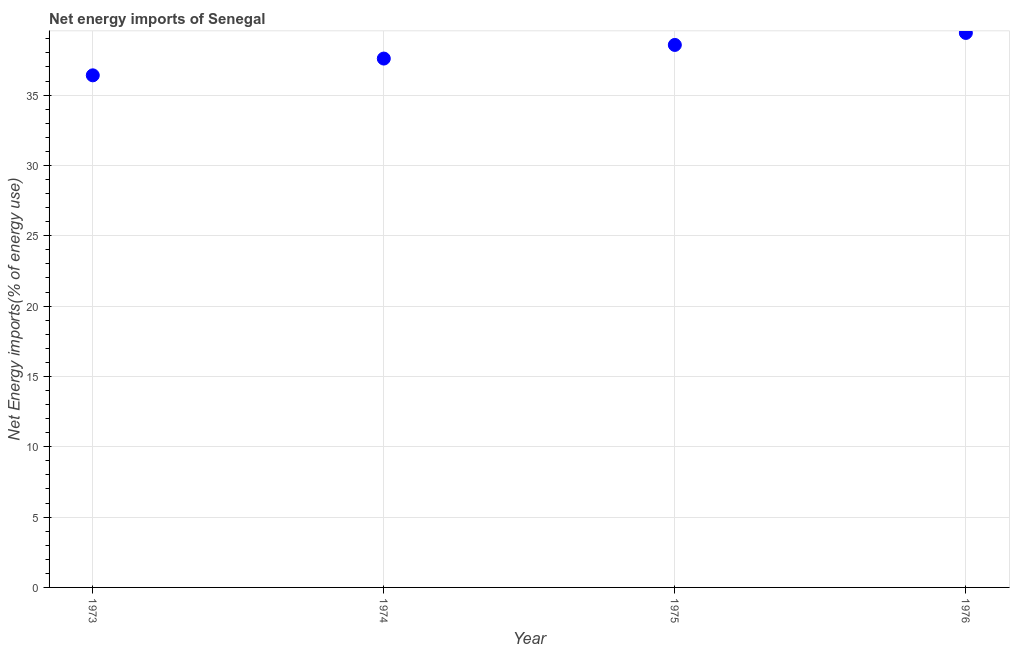What is the energy imports in 1976?
Provide a succinct answer. 39.42. Across all years, what is the maximum energy imports?
Provide a succinct answer. 39.42. Across all years, what is the minimum energy imports?
Keep it short and to the point. 36.4. In which year was the energy imports maximum?
Keep it short and to the point. 1976. In which year was the energy imports minimum?
Give a very brief answer. 1973. What is the sum of the energy imports?
Ensure brevity in your answer.  151.98. What is the difference between the energy imports in 1975 and 1976?
Make the answer very short. -0.85. What is the average energy imports per year?
Offer a terse response. 38. What is the median energy imports?
Your response must be concise. 38.08. What is the ratio of the energy imports in 1973 to that in 1975?
Give a very brief answer. 0.94. Is the difference between the energy imports in 1973 and 1974 greater than the difference between any two years?
Give a very brief answer. No. What is the difference between the highest and the second highest energy imports?
Make the answer very short. 0.85. What is the difference between the highest and the lowest energy imports?
Keep it short and to the point. 3.01. In how many years, is the energy imports greater than the average energy imports taken over all years?
Offer a very short reply. 2. How many years are there in the graph?
Offer a terse response. 4. Are the values on the major ticks of Y-axis written in scientific E-notation?
Your response must be concise. No. Does the graph contain any zero values?
Keep it short and to the point. No. Does the graph contain grids?
Your answer should be compact. Yes. What is the title of the graph?
Ensure brevity in your answer.  Net energy imports of Senegal. What is the label or title of the Y-axis?
Offer a terse response. Net Energy imports(% of energy use). What is the Net Energy imports(% of energy use) in 1973?
Ensure brevity in your answer.  36.4. What is the Net Energy imports(% of energy use) in 1974?
Offer a terse response. 37.6. What is the Net Energy imports(% of energy use) in 1975?
Ensure brevity in your answer.  38.57. What is the Net Energy imports(% of energy use) in 1976?
Provide a succinct answer. 39.42. What is the difference between the Net Energy imports(% of energy use) in 1973 and 1974?
Keep it short and to the point. -1.19. What is the difference between the Net Energy imports(% of energy use) in 1973 and 1975?
Provide a succinct answer. -2.16. What is the difference between the Net Energy imports(% of energy use) in 1973 and 1976?
Your answer should be very brief. -3.01. What is the difference between the Net Energy imports(% of energy use) in 1974 and 1975?
Your response must be concise. -0.97. What is the difference between the Net Energy imports(% of energy use) in 1974 and 1976?
Offer a very short reply. -1.82. What is the difference between the Net Energy imports(% of energy use) in 1975 and 1976?
Your response must be concise. -0.85. What is the ratio of the Net Energy imports(% of energy use) in 1973 to that in 1974?
Provide a short and direct response. 0.97. What is the ratio of the Net Energy imports(% of energy use) in 1973 to that in 1975?
Provide a succinct answer. 0.94. What is the ratio of the Net Energy imports(% of energy use) in 1973 to that in 1976?
Keep it short and to the point. 0.92. What is the ratio of the Net Energy imports(% of energy use) in 1974 to that in 1975?
Provide a short and direct response. 0.97. What is the ratio of the Net Energy imports(% of energy use) in 1974 to that in 1976?
Ensure brevity in your answer.  0.95. What is the ratio of the Net Energy imports(% of energy use) in 1975 to that in 1976?
Offer a very short reply. 0.98. 